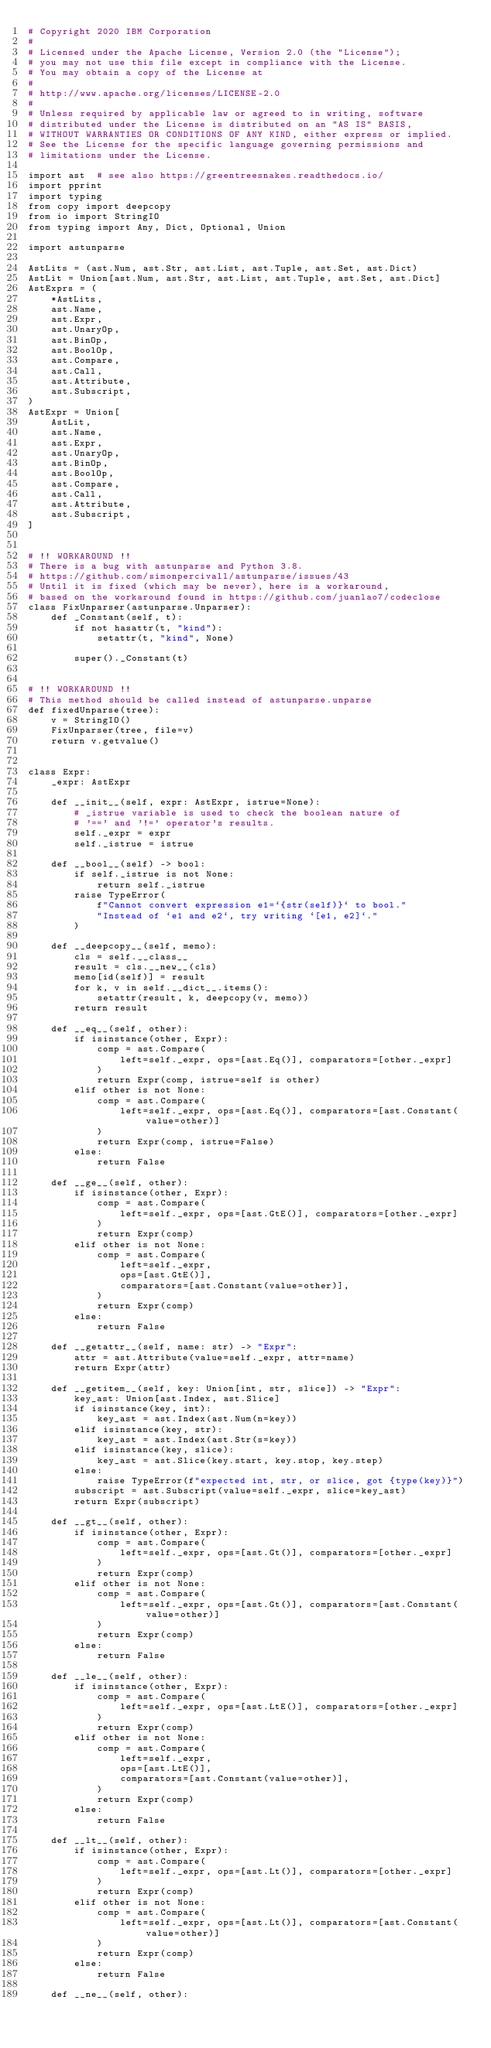Convert code to text. <code><loc_0><loc_0><loc_500><loc_500><_Python_># Copyright 2020 IBM Corporation
#
# Licensed under the Apache License, Version 2.0 (the "License");
# you may not use this file except in compliance with the License.
# You may obtain a copy of the License at
#
# http://www.apache.org/licenses/LICENSE-2.0
#
# Unless required by applicable law or agreed to in writing, software
# distributed under the License is distributed on an "AS IS" BASIS,
# WITHOUT WARRANTIES OR CONDITIONS OF ANY KIND, either express or implied.
# See the License for the specific language governing permissions and
# limitations under the License.

import ast  # see also https://greentreesnakes.readthedocs.io/
import pprint
import typing
from copy import deepcopy
from io import StringIO
from typing import Any, Dict, Optional, Union

import astunparse

AstLits = (ast.Num, ast.Str, ast.List, ast.Tuple, ast.Set, ast.Dict)
AstLit = Union[ast.Num, ast.Str, ast.List, ast.Tuple, ast.Set, ast.Dict]
AstExprs = (
    *AstLits,
    ast.Name,
    ast.Expr,
    ast.UnaryOp,
    ast.BinOp,
    ast.BoolOp,
    ast.Compare,
    ast.Call,
    ast.Attribute,
    ast.Subscript,
)
AstExpr = Union[
    AstLit,
    ast.Name,
    ast.Expr,
    ast.UnaryOp,
    ast.BinOp,
    ast.BoolOp,
    ast.Compare,
    ast.Call,
    ast.Attribute,
    ast.Subscript,
]


# !! WORKAROUND !!
# There is a bug with astunparse and Python 3.8.
# https://github.com/simonpercivall/astunparse/issues/43
# Until it is fixed (which may be never), here is a workaround,
# based on the workaround found in https://github.com/juanlao7/codeclose
class FixUnparser(astunparse.Unparser):
    def _Constant(self, t):
        if not hasattr(t, "kind"):
            setattr(t, "kind", None)

        super()._Constant(t)


# !! WORKAROUND !!
# This method should be called instead of astunparse.unparse
def fixedUnparse(tree):
    v = StringIO()
    FixUnparser(tree, file=v)
    return v.getvalue()


class Expr:
    _expr: AstExpr

    def __init__(self, expr: AstExpr, istrue=None):
        # _istrue variable is used to check the boolean nature of
        # '==' and '!=' operator's results.
        self._expr = expr
        self._istrue = istrue

    def __bool__(self) -> bool:
        if self._istrue is not None:
            return self._istrue
        raise TypeError(
            f"Cannot convert expression e1=`{str(self)}` to bool."
            "Instead of `e1 and e2`, try writing `[e1, e2]`."
        )

    def __deepcopy__(self, memo):
        cls = self.__class__
        result = cls.__new__(cls)
        memo[id(self)] = result
        for k, v in self.__dict__.items():
            setattr(result, k, deepcopy(v, memo))
        return result

    def __eq__(self, other):
        if isinstance(other, Expr):
            comp = ast.Compare(
                left=self._expr, ops=[ast.Eq()], comparators=[other._expr]
            )
            return Expr(comp, istrue=self is other)
        elif other is not None:
            comp = ast.Compare(
                left=self._expr, ops=[ast.Eq()], comparators=[ast.Constant(value=other)]
            )
            return Expr(comp, istrue=False)
        else:
            return False

    def __ge__(self, other):
        if isinstance(other, Expr):
            comp = ast.Compare(
                left=self._expr, ops=[ast.GtE()], comparators=[other._expr]
            )
            return Expr(comp)
        elif other is not None:
            comp = ast.Compare(
                left=self._expr,
                ops=[ast.GtE()],
                comparators=[ast.Constant(value=other)],
            )
            return Expr(comp)
        else:
            return False

    def __getattr__(self, name: str) -> "Expr":
        attr = ast.Attribute(value=self._expr, attr=name)
        return Expr(attr)

    def __getitem__(self, key: Union[int, str, slice]) -> "Expr":
        key_ast: Union[ast.Index, ast.Slice]
        if isinstance(key, int):
            key_ast = ast.Index(ast.Num(n=key))
        elif isinstance(key, str):
            key_ast = ast.Index(ast.Str(s=key))
        elif isinstance(key, slice):
            key_ast = ast.Slice(key.start, key.stop, key.step)
        else:
            raise TypeError(f"expected int, str, or slice, got {type(key)}")
        subscript = ast.Subscript(value=self._expr, slice=key_ast)
        return Expr(subscript)

    def __gt__(self, other):
        if isinstance(other, Expr):
            comp = ast.Compare(
                left=self._expr, ops=[ast.Gt()], comparators=[other._expr]
            )
            return Expr(comp)
        elif other is not None:
            comp = ast.Compare(
                left=self._expr, ops=[ast.Gt()], comparators=[ast.Constant(value=other)]
            )
            return Expr(comp)
        else:
            return False

    def __le__(self, other):
        if isinstance(other, Expr):
            comp = ast.Compare(
                left=self._expr, ops=[ast.LtE()], comparators=[other._expr]
            )
            return Expr(comp)
        elif other is not None:
            comp = ast.Compare(
                left=self._expr,
                ops=[ast.LtE()],
                comparators=[ast.Constant(value=other)],
            )
            return Expr(comp)
        else:
            return False

    def __lt__(self, other):
        if isinstance(other, Expr):
            comp = ast.Compare(
                left=self._expr, ops=[ast.Lt()], comparators=[other._expr]
            )
            return Expr(comp)
        elif other is not None:
            comp = ast.Compare(
                left=self._expr, ops=[ast.Lt()], comparators=[ast.Constant(value=other)]
            )
            return Expr(comp)
        else:
            return False

    def __ne__(self, other):</code> 